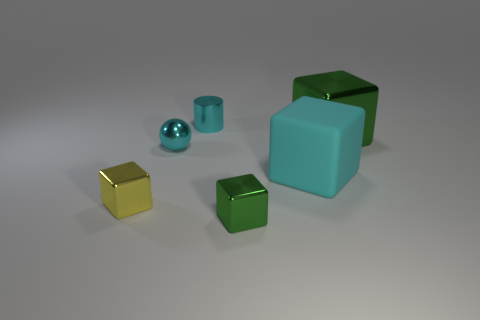Is there anything else that has the same material as the cyan block?
Your response must be concise. No. Is the number of small objects in front of the small yellow metallic object the same as the number of cyan balls that are in front of the cyan ball?
Your response must be concise. No. How big is the block behind the metal ball?
Your response must be concise. Large. Do the metal ball and the metal cylinder have the same color?
Make the answer very short. Yes. What material is the cube that is the same color as the metallic ball?
Ensure brevity in your answer.  Rubber. Are there the same number of cyan balls that are in front of the tiny cyan metal sphere and big green objects?
Provide a short and direct response. No. There is a big cyan matte thing; are there any large cyan objects on the right side of it?
Your response must be concise. No. Is the shape of the yellow metallic object the same as the green metal thing behind the big cyan rubber thing?
Provide a succinct answer. Yes. What color is the cylinder that is the same material as the small yellow thing?
Provide a short and direct response. Cyan. What color is the matte block?
Give a very brief answer. Cyan. 